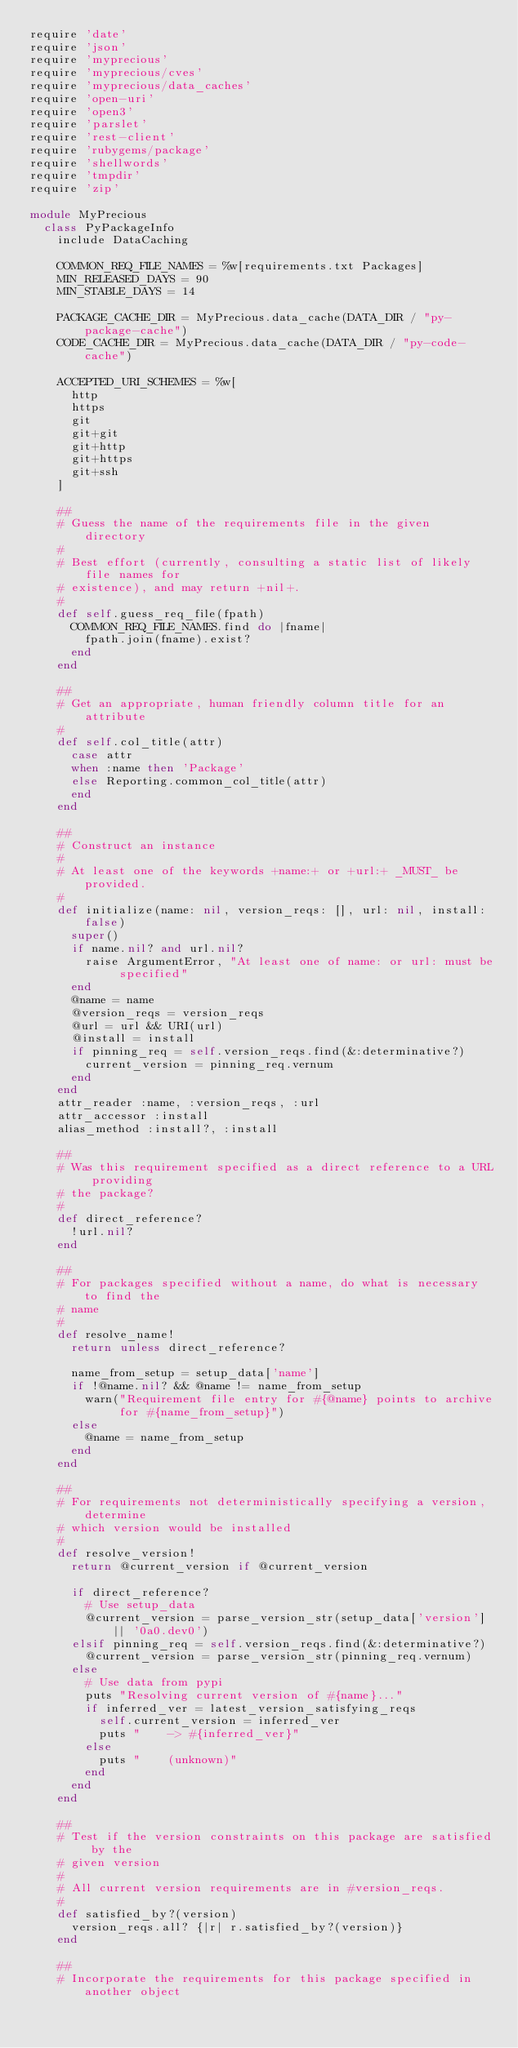<code> <loc_0><loc_0><loc_500><loc_500><_Ruby_>require 'date'
require 'json'
require 'myprecious'
require 'myprecious/cves'
require 'myprecious/data_caches'
require 'open-uri'
require 'open3'
require 'parslet'
require 'rest-client'
require 'rubygems/package'
require 'shellwords'
require 'tmpdir'
require 'zip'

module MyPrecious
  class PyPackageInfo
    include DataCaching
    
    COMMON_REQ_FILE_NAMES = %w[requirements.txt Packages]
    MIN_RELEASED_DAYS = 90
    MIN_STABLE_DAYS = 14
    
    PACKAGE_CACHE_DIR = MyPrecious.data_cache(DATA_DIR / "py-package-cache")
    CODE_CACHE_DIR = MyPrecious.data_cache(DATA_DIR / "py-code-cache")
    
    ACCEPTED_URI_SCHEMES = %w[
      http
      https
      git
      git+git
      git+http
      git+https
      git+ssh
    ]
    
    ##
    # Guess the name of the requirements file in the given directory
    #
    # Best effort (currently, consulting a static list of likely file names for
    # existence), and may return +nil+.
    #
    def self.guess_req_file(fpath)
      COMMON_REQ_FILE_NAMES.find do |fname|
        fpath.join(fname).exist?
      end
    end
    
    ##
    # Get an appropriate, human friendly column title for an attribute
    #
    def self.col_title(attr)
      case attr
      when :name then 'Package'
      else Reporting.common_col_title(attr)
      end
    end
    
    ##
    # Construct an instance
    #
    # At least one of the keywords +name:+ or +url:+ _MUST_ be provided.
    #
    def initialize(name: nil, version_reqs: [], url: nil, install: false)
      super()
      if name.nil? and url.nil?
        raise ArgumentError, "At least one of name: or url: must be specified"
      end
      @name = name
      @version_reqs = version_reqs
      @url = url && URI(url)
      @install = install
      if pinning_req = self.version_reqs.find(&:determinative?)
        current_version = pinning_req.vernum
      end
    end
    attr_reader :name, :version_reqs, :url
    attr_accessor :install
    alias_method :install?, :install
    
    ##
    # Was this requirement specified as a direct reference to a URL providing
    # the package?
    #
    def direct_reference?
      !url.nil?
    end
    
    ##
    # For packages specified without a name, do what is necessary to find the
    # name
    #
    def resolve_name!
      return unless direct_reference?
      
      name_from_setup = setup_data['name']
      if !@name.nil? && @name != name_from_setup
        warn("Requirement file entry for #{@name} points to archive for #{name_from_setup}")
      else
        @name = name_from_setup
      end
    end
    
    ##
    # For requirements not deterministically specifying a version, determine
    # which version would be installed
    #
    def resolve_version!
      return @current_version if @current_version
      
      if direct_reference?
        # Use setup_data
        @current_version = parse_version_str(setup_data['version'] || '0a0.dev0')
      elsif pinning_req = self.version_reqs.find(&:determinative?)
        @current_version = parse_version_str(pinning_req.vernum)
      else
        # Use data from pypi
        puts "Resolving current version of #{name}..."
        if inferred_ver = latest_version_satisfying_reqs
          self.current_version = inferred_ver
          puts "    -> #{inferred_ver}"
        else
          puts "    (unknown)"
        end
      end
    end
    
    ##
    # Test if the version constraints on this package are satisfied by the
    # given version
    #
    # All current version requirements are in #version_reqs.
    #
    def satisfied_by?(version)
      version_reqs.all? {|r| r.satisfied_by?(version)}
    end
    
    ##
    # Incorporate the requirements for this package specified in another object</code> 